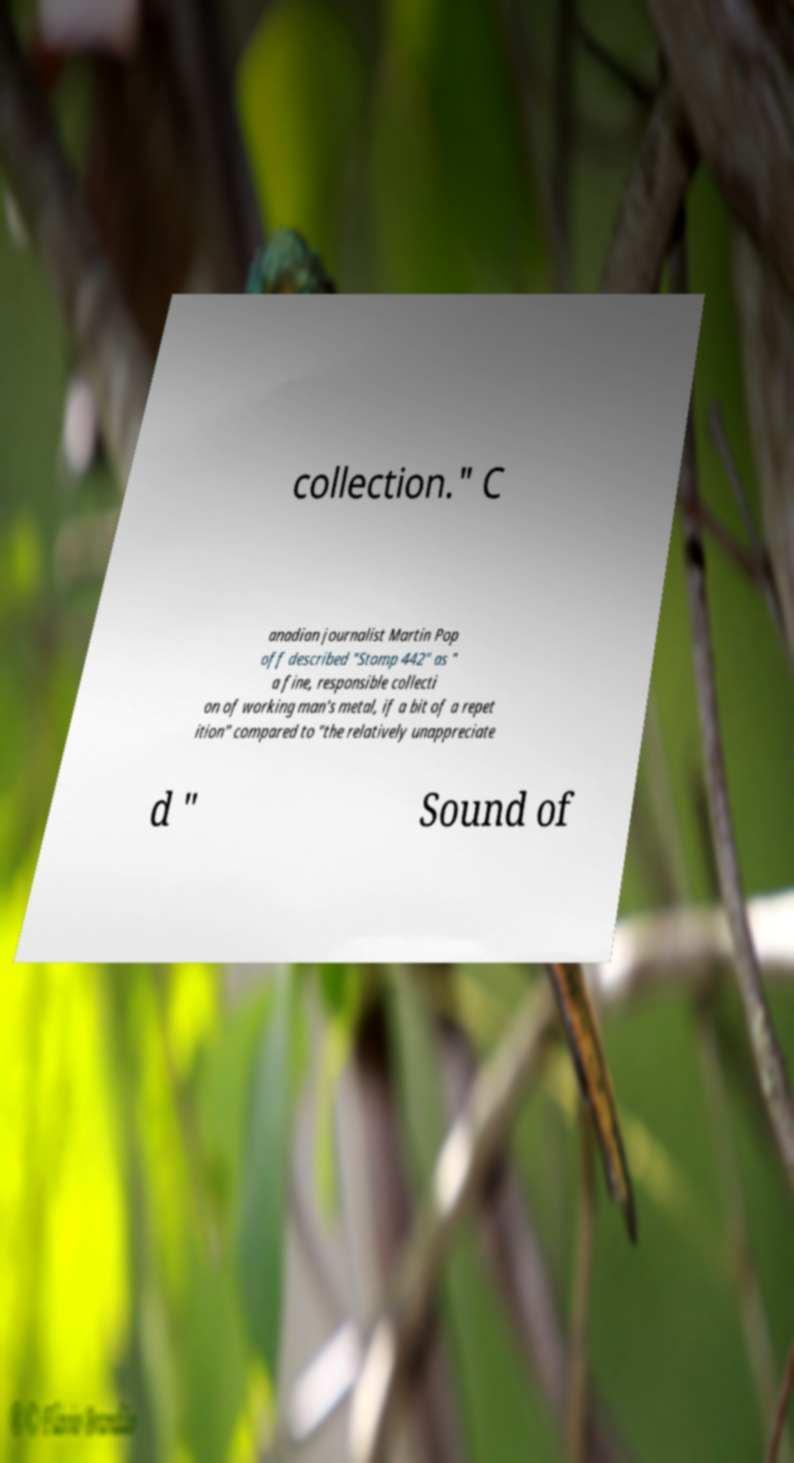For documentation purposes, I need the text within this image transcribed. Could you provide that? collection." C anadian journalist Martin Pop off described "Stomp 442" as " a fine, responsible collecti on of working man's metal, if a bit of a repet ition" compared to "the relatively unappreciate d " Sound of 